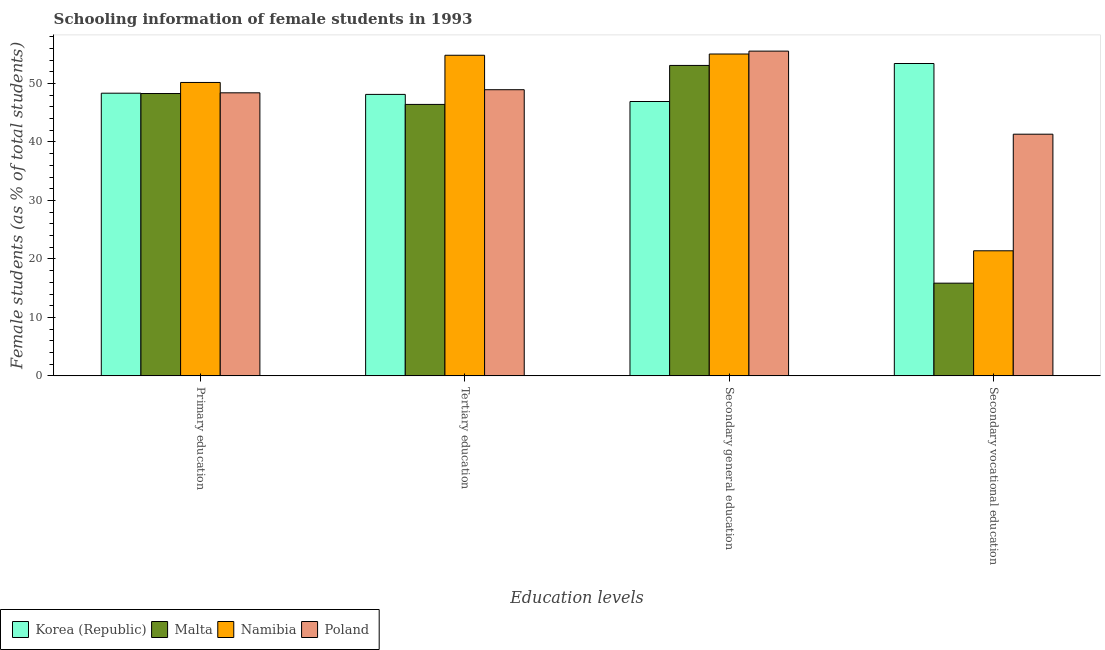Are the number of bars per tick equal to the number of legend labels?
Provide a short and direct response. Yes. Are the number of bars on each tick of the X-axis equal?
Ensure brevity in your answer.  Yes. How many bars are there on the 2nd tick from the left?
Give a very brief answer. 4. How many bars are there on the 2nd tick from the right?
Keep it short and to the point. 4. What is the percentage of female students in tertiary education in Namibia?
Your answer should be very brief. 54.83. Across all countries, what is the maximum percentage of female students in tertiary education?
Provide a succinct answer. 54.83. Across all countries, what is the minimum percentage of female students in tertiary education?
Provide a succinct answer. 46.43. In which country was the percentage of female students in primary education minimum?
Ensure brevity in your answer.  Malta. What is the total percentage of female students in secondary vocational education in the graph?
Your answer should be very brief. 132. What is the difference between the percentage of female students in secondary vocational education in Korea (Republic) and that in Malta?
Your answer should be compact. 37.57. What is the difference between the percentage of female students in secondary vocational education in Namibia and the percentage of female students in secondary education in Malta?
Your answer should be very brief. -31.7. What is the average percentage of female students in primary education per country?
Give a very brief answer. 48.81. What is the difference between the percentage of female students in tertiary education and percentage of female students in secondary education in Namibia?
Offer a very short reply. -0.21. What is the ratio of the percentage of female students in tertiary education in Poland to that in Korea (Republic)?
Make the answer very short. 1.02. Is the difference between the percentage of female students in secondary vocational education in Namibia and Korea (Republic) greater than the difference between the percentage of female students in secondary education in Namibia and Korea (Republic)?
Your answer should be compact. No. What is the difference between the highest and the second highest percentage of female students in secondary vocational education?
Ensure brevity in your answer.  12.09. What is the difference between the highest and the lowest percentage of female students in tertiary education?
Offer a terse response. 8.41. What does the 3rd bar from the left in Primary education represents?
Offer a very short reply. Namibia. What does the 3rd bar from the right in Secondary general education represents?
Provide a succinct answer. Malta. How many bars are there?
Your response must be concise. 16. Are all the bars in the graph horizontal?
Offer a terse response. No. How many countries are there in the graph?
Offer a terse response. 4. Does the graph contain any zero values?
Give a very brief answer. No. Does the graph contain grids?
Provide a short and direct response. No. Where does the legend appear in the graph?
Ensure brevity in your answer.  Bottom left. What is the title of the graph?
Keep it short and to the point. Schooling information of female students in 1993. What is the label or title of the X-axis?
Provide a short and direct response. Education levels. What is the label or title of the Y-axis?
Keep it short and to the point. Female students (as % of total students). What is the Female students (as % of total students) in Korea (Republic) in Primary education?
Your response must be concise. 48.35. What is the Female students (as % of total students) in Malta in Primary education?
Ensure brevity in your answer.  48.29. What is the Female students (as % of total students) in Namibia in Primary education?
Offer a very short reply. 50.18. What is the Female students (as % of total students) in Poland in Primary education?
Your answer should be compact. 48.41. What is the Female students (as % of total students) of Korea (Republic) in Tertiary education?
Ensure brevity in your answer.  48.14. What is the Female students (as % of total students) of Malta in Tertiary education?
Your response must be concise. 46.43. What is the Female students (as % of total students) of Namibia in Tertiary education?
Make the answer very short. 54.83. What is the Female students (as % of total students) of Poland in Tertiary education?
Your answer should be very brief. 48.94. What is the Female students (as % of total students) of Korea (Republic) in Secondary general education?
Offer a terse response. 46.92. What is the Female students (as % of total students) in Malta in Secondary general education?
Make the answer very short. 53.09. What is the Female students (as % of total students) of Namibia in Secondary general education?
Offer a very short reply. 55.05. What is the Female students (as % of total students) of Poland in Secondary general education?
Offer a terse response. 55.54. What is the Female students (as % of total students) of Korea (Republic) in Secondary vocational education?
Ensure brevity in your answer.  53.42. What is the Female students (as % of total students) in Malta in Secondary vocational education?
Keep it short and to the point. 15.85. What is the Female students (as % of total students) in Namibia in Secondary vocational education?
Offer a very short reply. 21.39. What is the Female students (as % of total students) of Poland in Secondary vocational education?
Offer a very short reply. 41.33. Across all Education levels, what is the maximum Female students (as % of total students) of Korea (Republic)?
Ensure brevity in your answer.  53.42. Across all Education levels, what is the maximum Female students (as % of total students) in Malta?
Your answer should be compact. 53.09. Across all Education levels, what is the maximum Female students (as % of total students) in Namibia?
Give a very brief answer. 55.05. Across all Education levels, what is the maximum Female students (as % of total students) of Poland?
Give a very brief answer. 55.54. Across all Education levels, what is the minimum Female students (as % of total students) in Korea (Republic)?
Keep it short and to the point. 46.92. Across all Education levels, what is the minimum Female students (as % of total students) of Malta?
Your response must be concise. 15.85. Across all Education levels, what is the minimum Female students (as % of total students) of Namibia?
Provide a short and direct response. 21.39. Across all Education levels, what is the minimum Female students (as % of total students) in Poland?
Keep it short and to the point. 41.33. What is the total Female students (as % of total students) in Korea (Republic) in the graph?
Ensure brevity in your answer.  196.83. What is the total Female students (as % of total students) in Malta in the graph?
Keep it short and to the point. 163.66. What is the total Female students (as % of total students) in Namibia in the graph?
Ensure brevity in your answer.  181.45. What is the total Female students (as % of total students) in Poland in the graph?
Your answer should be compact. 194.23. What is the difference between the Female students (as % of total students) of Korea (Republic) in Primary education and that in Tertiary education?
Provide a succinct answer. 0.21. What is the difference between the Female students (as % of total students) in Malta in Primary education and that in Tertiary education?
Offer a very short reply. 1.86. What is the difference between the Female students (as % of total students) in Namibia in Primary education and that in Tertiary education?
Your response must be concise. -4.65. What is the difference between the Female students (as % of total students) in Poland in Primary education and that in Tertiary education?
Provide a short and direct response. -0.53. What is the difference between the Female students (as % of total students) in Korea (Republic) in Primary education and that in Secondary general education?
Your answer should be compact. 1.42. What is the difference between the Female students (as % of total students) in Malta in Primary education and that in Secondary general education?
Provide a succinct answer. -4.81. What is the difference between the Female students (as % of total students) of Namibia in Primary education and that in Secondary general education?
Your answer should be compact. -4.87. What is the difference between the Female students (as % of total students) in Poland in Primary education and that in Secondary general education?
Offer a very short reply. -7.13. What is the difference between the Female students (as % of total students) in Korea (Republic) in Primary education and that in Secondary vocational education?
Give a very brief answer. -5.08. What is the difference between the Female students (as % of total students) of Malta in Primary education and that in Secondary vocational education?
Provide a short and direct response. 32.43. What is the difference between the Female students (as % of total students) in Namibia in Primary education and that in Secondary vocational education?
Keep it short and to the point. 28.79. What is the difference between the Female students (as % of total students) of Poland in Primary education and that in Secondary vocational education?
Offer a terse response. 7.08. What is the difference between the Female students (as % of total students) in Korea (Republic) in Tertiary education and that in Secondary general education?
Provide a succinct answer. 1.22. What is the difference between the Female students (as % of total students) in Malta in Tertiary education and that in Secondary general education?
Keep it short and to the point. -6.67. What is the difference between the Female students (as % of total students) of Namibia in Tertiary education and that in Secondary general education?
Ensure brevity in your answer.  -0.21. What is the difference between the Female students (as % of total students) in Poland in Tertiary education and that in Secondary general education?
Keep it short and to the point. -6.6. What is the difference between the Female students (as % of total students) of Korea (Republic) in Tertiary education and that in Secondary vocational education?
Your response must be concise. -5.28. What is the difference between the Female students (as % of total students) in Malta in Tertiary education and that in Secondary vocational education?
Offer a terse response. 30.57. What is the difference between the Female students (as % of total students) in Namibia in Tertiary education and that in Secondary vocational education?
Your answer should be very brief. 33.44. What is the difference between the Female students (as % of total students) in Poland in Tertiary education and that in Secondary vocational education?
Offer a very short reply. 7.61. What is the difference between the Female students (as % of total students) in Korea (Republic) in Secondary general education and that in Secondary vocational education?
Ensure brevity in your answer.  -6.5. What is the difference between the Female students (as % of total students) of Malta in Secondary general education and that in Secondary vocational education?
Ensure brevity in your answer.  37.24. What is the difference between the Female students (as % of total students) of Namibia in Secondary general education and that in Secondary vocational education?
Provide a short and direct response. 33.65. What is the difference between the Female students (as % of total students) in Poland in Secondary general education and that in Secondary vocational education?
Your answer should be compact. 14.21. What is the difference between the Female students (as % of total students) in Korea (Republic) in Primary education and the Female students (as % of total students) in Malta in Tertiary education?
Your answer should be very brief. 1.92. What is the difference between the Female students (as % of total students) in Korea (Republic) in Primary education and the Female students (as % of total students) in Namibia in Tertiary education?
Keep it short and to the point. -6.49. What is the difference between the Female students (as % of total students) in Korea (Republic) in Primary education and the Female students (as % of total students) in Poland in Tertiary education?
Your answer should be very brief. -0.6. What is the difference between the Female students (as % of total students) of Malta in Primary education and the Female students (as % of total students) of Namibia in Tertiary education?
Your answer should be very brief. -6.54. What is the difference between the Female students (as % of total students) in Malta in Primary education and the Female students (as % of total students) in Poland in Tertiary education?
Make the answer very short. -0.65. What is the difference between the Female students (as % of total students) in Namibia in Primary education and the Female students (as % of total students) in Poland in Tertiary education?
Your answer should be compact. 1.24. What is the difference between the Female students (as % of total students) of Korea (Republic) in Primary education and the Female students (as % of total students) of Malta in Secondary general education?
Offer a terse response. -4.75. What is the difference between the Female students (as % of total students) in Korea (Republic) in Primary education and the Female students (as % of total students) in Namibia in Secondary general education?
Your answer should be compact. -6.7. What is the difference between the Female students (as % of total students) of Korea (Republic) in Primary education and the Female students (as % of total students) of Poland in Secondary general education?
Your response must be concise. -7.2. What is the difference between the Female students (as % of total students) of Malta in Primary education and the Female students (as % of total students) of Namibia in Secondary general education?
Provide a succinct answer. -6.76. What is the difference between the Female students (as % of total students) of Malta in Primary education and the Female students (as % of total students) of Poland in Secondary general education?
Keep it short and to the point. -7.25. What is the difference between the Female students (as % of total students) of Namibia in Primary education and the Female students (as % of total students) of Poland in Secondary general education?
Keep it short and to the point. -5.36. What is the difference between the Female students (as % of total students) in Korea (Republic) in Primary education and the Female students (as % of total students) in Malta in Secondary vocational education?
Keep it short and to the point. 32.49. What is the difference between the Female students (as % of total students) in Korea (Republic) in Primary education and the Female students (as % of total students) in Namibia in Secondary vocational education?
Your answer should be very brief. 26.95. What is the difference between the Female students (as % of total students) in Korea (Republic) in Primary education and the Female students (as % of total students) in Poland in Secondary vocational education?
Give a very brief answer. 7.01. What is the difference between the Female students (as % of total students) in Malta in Primary education and the Female students (as % of total students) in Namibia in Secondary vocational education?
Make the answer very short. 26.9. What is the difference between the Female students (as % of total students) of Malta in Primary education and the Female students (as % of total students) of Poland in Secondary vocational education?
Make the answer very short. 6.96. What is the difference between the Female students (as % of total students) in Namibia in Primary education and the Female students (as % of total students) in Poland in Secondary vocational education?
Provide a short and direct response. 8.85. What is the difference between the Female students (as % of total students) in Korea (Republic) in Tertiary education and the Female students (as % of total students) in Malta in Secondary general education?
Offer a very short reply. -4.96. What is the difference between the Female students (as % of total students) in Korea (Republic) in Tertiary education and the Female students (as % of total students) in Namibia in Secondary general education?
Ensure brevity in your answer.  -6.91. What is the difference between the Female students (as % of total students) in Korea (Republic) in Tertiary education and the Female students (as % of total students) in Poland in Secondary general education?
Offer a terse response. -7.4. What is the difference between the Female students (as % of total students) of Malta in Tertiary education and the Female students (as % of total students) of Namibia in Secondary general education?
Offer a very short reply. -8.62. What is the difference between the Female students (as % of total students) in Malta in Tertiary education and the Female students (as % of total students) in Poland in Secondary general education?
Offer a terse response. -9.12. What is the difference between the Female students (as % of total students) in Namibia in Tertiary education and the Female students (as % of total students) in Poland in Secondary general education?
Your response must be concise. -0.71. What is the difference between the Female students (as % of total students) of Korea (Republic) in Tertiary education and the Female students (as % of total students) of Malta in Secondary vocational education?
Provide a short and direct response. 32.28. What is the difference between the Female students (as % of total students) in Korea (Republic) in Tertiary education and the Female students (as % of total students) in Namibia in Secondary vocational education?
Offer a terse response. 26.75. What is the difference between the Female students (as % of total students) of Korea (Republic) in Tertiary education and the Female students (as % of total students) of Poland in Secondary vocational education?
Your response must be concise. 6.81. What is the difference between the Female students (as % of total students) of Malta in Tertiary education and the Female students (as % of total students) of Namibia in Secondary vocational education?
Give a very brief answer. 25.03. What is the difference between the Female students (as % of total students) of Malta in Tertiary education and the Female students (as % of total students) of Poland in Secondary vocational education?
Your response must be concise. 5.09. What is the difference between the Female students (as % of total students) in Namibia in Tertiary education and the Female students (as % of total students) in Poland in Secondary vocational education?
Keep it short and to the point. 13.5. What is the difference between the Female students (as % of total students) of Korea (Republic) in Secondary general education and the Female students (as % of total students) of Malta in Secondary vocational education?
Keep it short and to the point. 31.07. What is the difference between the Female students (as % of total students) of Korea (Republic) in Secondary general education and the Female students (as % of total students) of Namibia in Secondary vocational education?
Your answer should be very brief. 25.53. What is the difference between the Female students (as % of total students) in Korea (Republic) in Secondary general education and the Female students (as % of total students) in Poland in Secondary vocational education?
Your answer should be compact. 5.59. What is the difference between the Female students (as % of total students) of Malta in Secondary general education and the Female students (as % of total students) of Namibia in Secondary vocational education?
Offer a very short reply. 31.7. What is the difference between the Female students (as % of total students) of Malta in Secondary general education and the Female students (as % of total students) of Poland in Secondary vocational education?
Offer a very short reply. 11.76. What is the difference between the Female students (as % of total students) in Namibia in Secondary general education and the Female students (as % of total students) in Poland in Secondary vocational education?
Your answer should be compact. 13.72. What is the average Female students (as % of total students) of Korea (Republic) per Education levels?
Provide a succinct answer. 49.21. What is the average Female students (as % of total students) of Malta per Education levels?
Keep it short and to the point. 40.92. What is the average Female students (as % of total students) of Namibia per Education levels?
Offer a very short reply. 45.36. What is the average Female students (as % of total students) in Poland per Education levels?
Ensure brevity in your answer.  48.56. What is the difference between the Female students (as % of total students) of Korea (Republic) and Female students (as % of total students) of Malta in Primary education?
Your answer should be very brief. 0.06. What is the difference between the Female students (as % of total students) in Korea (Republic) and Female students (as % of total students) in Namibia in Primary education?
Offer a terse response. -1.84. What is the difference between the Female students (as % of total students) in Korea (Republic) and Female students (as % of total students) in Poland in Primary education?
Offer a very short reply. -0.06. What is the difference between the Female students (as % of total students) in Malta and Female students (as % of total students) in Namibia in Primary education?
Your response must be concise. -1.89. What is the difference between the Female students (as % of total students) of Malta and Female students (as % of total students) of Poland in Primary education?
Your response must be concise. -0.12. What is the difference between the Female students (as % of total students) in Namibia and Female students (as % of total students) in Poland in Primary education?
Make the answer very short. 1.77. What is the difference between the Female students (as % of total students) of Korea (Republic) and Female students (as % of total students) of Malta in Tertiary education?
Your answer should be compact. 1.71. What is the difference between the Female students (as % of total students) in Korea (Republic) and Female students (as % of total students) in Namibia in Tertiary education?
Provide a succinct answer. -6.69. What is the difference between the Female students (as % of total students) in Korea (Republic) and Female students (as % of total students) in Poland in Tertiary education?
Offer a very short reply. -0.8. What is the difference between the Female students (as % of total students) of Malta and Female students (as % of total students) of Namibia in Tertiary education?
Make the answer very short. -8.41. What is the difference between the Female students (as % of total students) of Malta and Female students (as % of total students) of Poland in Tertiary education?
Give a very brief answer. -2.52. What is the difference between the Female students (as % of total students) of Namibia and Female students (as % of total students) of Poland in Tertiary education?
Offer a terse response. 5.89. What is the difference between the Female students (as % of total students) in Korea (Republic) and Female students (as % of total students) in Malta in Secondary general education?
Provide a short and direct response. -6.17. What is the difference between the Female students (as % of total students) of Korea (Republic) and Female students (as % of total students) of Namibia in Secondary general education?
Offer a terse response. -8.12. What is the difference between the Female students (as % of total students) in Korea (Republic) and Female students (as % of total students) in Poland in Secondary general education?
Offer a very short reply. -8.62. What is the difference between the Female students (as % of total students) of Malta and Female students (as % of total students) of Namibia in Secondary general education?
Provide a short and direct response. -1.95. What is the difference between the Female students (as % of total students) of Malta and Female students (as % of total students) of Poland in Secondary general education?
Your answer should be very brief. -2.45. What is the difference between the Female students (as % of total students) of Namibia and Female students (as % of total students) of Poland in Secondary general education?
Your answer should be very brief. -0.5. What is the difference between the Female students (as % of total students) in Korea (Republic) and Female students (as % of total students) in Malta in Secondary vocational education?
Ensure brevity in your answer.  37.57. What is the difference between the Female students (as % of total students) in Korea (Republic) and Female students (as % of total students) in Namibia in Secondary vocational education?
Your answer should be compact. 32.03. What is the difference between the Female students (as % of total students) in Korea (Republic) and Female students (as % of total students) in Poland in Secondary vocational education?
Your answer should be very brief. 12.09. What is the difference between the Female students (as % of total students) of Malta and Female students (as % of total students) of Namibia in Secondary vocational education?
Your response must be concise. -5.54. What is the difference between the Female students (as % of total students) in Malta and Female students (as % of total students) in Poland in Secondary vocational education?
Give a very brief answer. -25.48. What is the difference between the Female students (as % of total students) of Namibia and Female students (as % of total students) of Poland in Secondary vocational education?
Keep it short and to the point. -19.94. What is the ratio of the Female students (as % of total students) in Malta in Primary education to that in Tertiary education?
Ensure brevity in your answer.  1.04. What is the ratio of the Female students (as % of total students) in Namibia in Primary education to that in Tertiary education?
Ensure brevity in your answer.  0.92. What is the ratio of the Female students (as % of total students) of Poland in Primary education to that in Tertiary education?
Give a very brief answer. 0.99. What is the ratio of the Female students (as % of total students) of Korea (Republic) in Primary education to that in Secondary general education?
Make the answer very short. 1.03. What is the ratio of the Female students (as % of total students) in Malta in Primary education to that in Secondary general education?
Keep it short and to the point. 0.91. What is the ratio of the Female students (as % of total students) of Namibia in Primary education to that in Secondary general education?
Provide a succinct answer. 0.91. What is the ratio of the Female students (as % of total students) of Poland in Primary education to that in Secondary general education?
Your answer should be compact. 0.87. What is the ratio of the Female students (as % of total students) in Korea (Republic) in Primary education to that in Secondary vocational education?
Give a very brief answer. 0.91. What is the ratio of the Female students (as % of total students) in Malta in Primary education to that in Secondary vocational education?
Make the answer very short. 3.05. What is the ratio of the Female students (as % of total students) of Namibia in Primary education to that in Secondary vocational education?
Offer a very short reply. 2.35. What is the ratio of the Female students (as % of total students) of Poland in Primary education to that in Secondary vocational education?
Your answer should be very brief. 1.17. What is the ratio of the Female students (as % of total students) in Korea (Republic) in Tertiary education to that in Secondary general education?
Your answer should be compact. 1.03. What is the ratio of the Female students (as % of total students) of Malta in Tertiary education to that in Secondary general education?
Offer a terse response. 0.87. What is the ratio of the Female students (as % of total students) in Namibia in Tertiary education to that in Secondary general education?
Provide a short and direct response. 1. What is the ratio of the Female students (as % of total students) in Poland in Tertiary education to that in Secondary general education?
Your response must be concise. 0.88. What is the ratio of the Female students (as % of total students) in Korea (Republic) in Tertiary education to that in Secondary vocational education?
Your answer should be very brief. 0.9. What is the ratio of the Female students (as % of total students) in Malta in Tertiary education to that in Secondary vocational education?
Give a very brief answer. 2.93. What is the ratio of the Female students (as % of total students) of Namibia in Tertiary education to that in Secondary vocational education?
Ensure brevity in your answer.  2.56. What is the ratio of the Female students (as % of total students) of Poland in Tertiary education to that in Secondary vocational education?
Your answer should be compact. 1.18. What is the ratio of the Female students (as % of total students) in Korea (Republic) in Secondary general education to that in Secondary vocational education?
Your answer should be very brief. 0.88. What is the ratio of the Female students (as % of total students) in Malta in Secondary general education to that in Secondary vocational education?
Ensure brevity in your answer.  3.35. What is the ratio of the Female students (as % of total students) in Namibia in Secondary general education to that in Secondary vocational education?
Provide a short and direct response. 2.57. What is the ratio of the Female students (as % of total students) in Poland in Secondary general education to that in Secondary vocational education?
Offer a very short reply. 1.34. What is the difference between the highest and the second highest Female students (as % of total students) in Korea (Republic)?
Offer a terse response. 5.08. What is the difference between the highest and the second highest Female students (as % of total students) in Malta?
Your answer should be compact. 4.81. What is the difference between the highest and the second highest Female students (as % of total students) in Namibia?
Make the answer very short. 0.21. What is the difference between the highest and the second highest Female students (as % of total students) in Poland?
Your response must be concise. 6.6. What is the difference between the highest and the lowest Female students (as % of total students) of Korea (Republic)?
Make the answer very short. 6.5. What is the difference between the highest and the lowest Female students (as % of total students) of Malta?
Provide a short and direct response. 37.24. What is the difference between the highest and the lowest Female students (as % of total students) in Namibia?
Your answer should be very brief. 33.65. What is the difference between the highest and the lowest Female students (as % of total students) of Poland?
Make the answer very short. 14.21. 